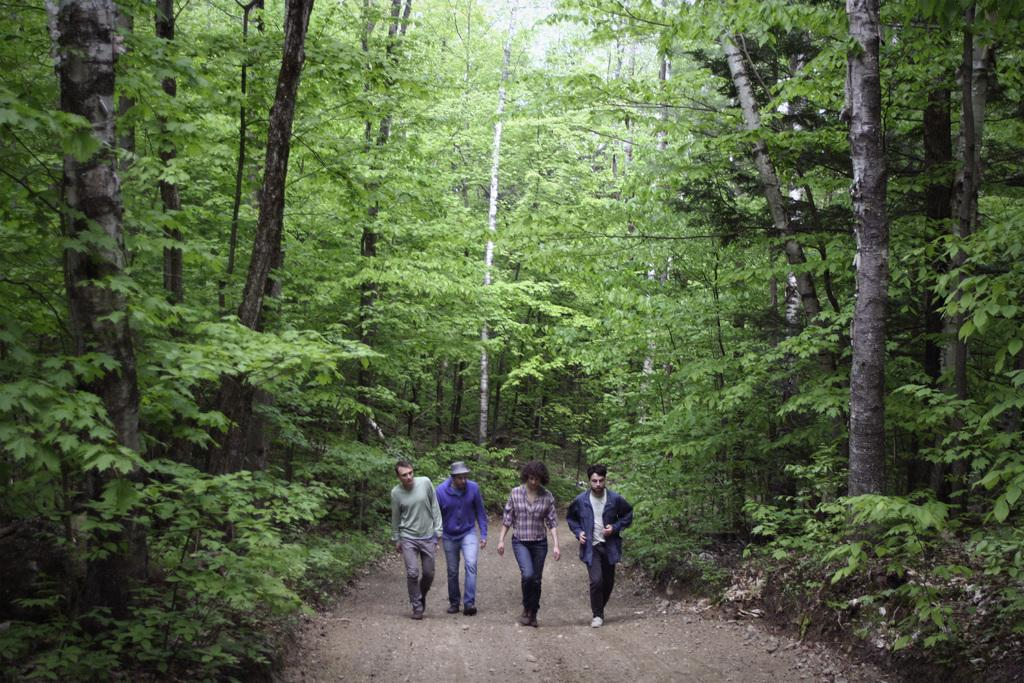Who or what can be seen in the image? There are people in the image. What is the position of the people in the image? The people are on the ground. What can be seen in the distance behind the people? There are trees in the background of the image. What type of hair can be seen on the trees in the image? There is no hair present on the trees in the image; they are simply trees in the background. 